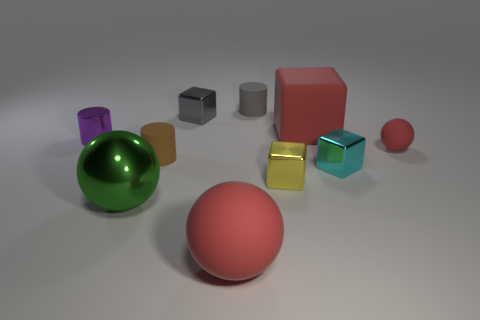Is there a cyan cylinder made of the same material as the yellow block?
Offer a very short reply. No. There is a sphere that is to the left of the tiny gray rubber thing and right of the green object; what color is it?
Offer a very short reply. Red. There is a cylinder that is to the left of the large green metallic ball; what material is it?
Keep it short and to the point. Metal. Is there another small yellow matte thing of the same shape as the yellow thing?
Offer a very short reply. No. How many other things are the same shape as the small red thing?
Ensure brevity in your answer.  2. There is a purple object; does it have the same shape as the brown rubber object that is behind the tiny yellow thing?
Give a very brief answer. Yes. There is a brown thing that is the same shape as the small gray rubber object; what material is it?
Offer a very short reply. Rubber. How many tiny things are brown things or metallic spheres?
Offer a very short reply. 1. Is the number of purple cylinders that are to the left of the brown rubber object less than the number of metallic objects on the left side of the large cube?
Make the answer very short. Yes. What number of things are purple cylinders or tiny yellow blocks?
Keep it short and to the point. 2. 